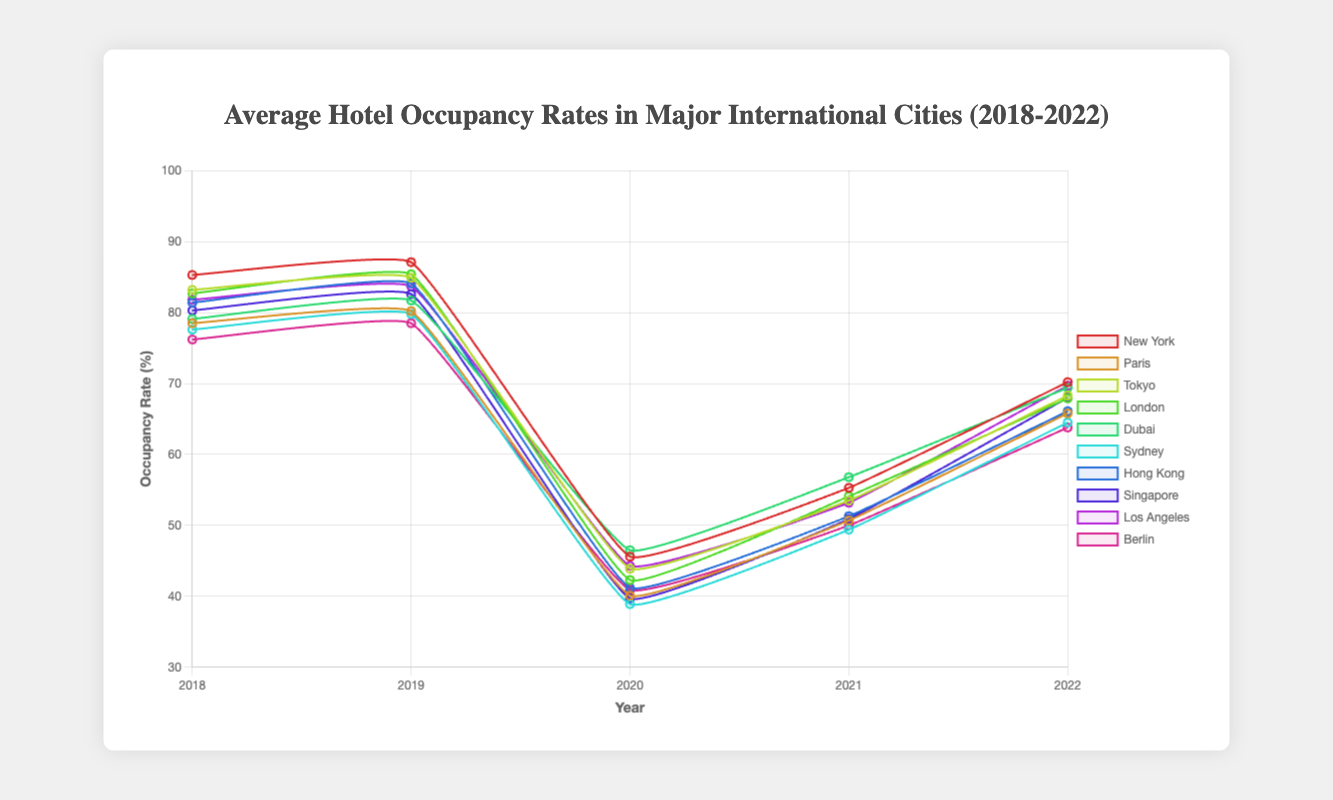Which city had the highest hotel occupancy rate in 2019? To find the city with the highest occupancy rate in 2019, look at the dataset for 2019 and identify the city with the highest percentage. New York has the highest occupancy rate at 87.1%.
Answer: New York How did the occupancy rate of New York change from 2019 to 2020? To identify the change, subtract the 2020 occupancy rate of New York (45.6%) from the 2019 occupancy rate (87.1%). The change is 87.1% - 45.6% = 41.5%.
Answer: Decreased by 41.5% Which city had the lowest occupancy rate in 2021? Reviewing the data for 2021, Sydney had the lowest occupancy rate at 49.4%.
Answer: Sydney Among Paris, Tokyo, and London, which city had the highest average occupancy rate over the five years? Calculate the average for each city by summing their annual occupancy rates and dividing by 5. Paris: (78.5 + 80.2 + 40.1 + 50.7 + 65.8) / 5 = 63.06%, Tokyo: (83.2 + 84.9 + 43.9 + 53.5 + 68.3) / 5 = 66.76%, London: (82.7 + 85.4 + 42.3 + 54.1 + 67.9) / 5 = 66.48%. Tokyo has the highest average.
Answer: Tokyo Which city's occupancy rate returned closest to its 2018 value by 2022? Compare the 2022 occupancy rate of each city with their 2018 rate and find the smallest difference. New York: 15.1%, Paris: 12.7%, Tokyo: 14.9%, London: 15.2%, Dubai: 9.7%, Sydney: 13.1%, Hong Kong: 15.3%, Singapore: 12.3%, Los Angeles: 12.1%, Berlin: 12.4%. Singapore has the smallest difference.
Answer: Singapore Did any city's occupancy rate increase continuously between 2020 and 2022? Observe the rates for each city between 2020 and 2022 to identify continuous increase. New York: Yes (45.6, 55.3, 70.2), Paris: Yes (40.1, 50.7, 65.8), Tokyo: Yes (43.9, 53.5, 68.3), London: Yes (42.3, 54.1, 67.9), Dubai: Yes (46.5, 56.8, 69.4), Sydney: Yes (38.9, 49.4, 64.5), Hong Kong: Yes (41.2, 51.3, 66.1), Singapore: Yes (39.7, 50.9, 68), Los Angeles: Yes (44.3, 53.2, 69.7), Berlin: Yes (40.9, 50.0, 63.8). All cities show an increase.
Answer: All cities Which city saw the highest occupancy rate drop between any two consecutive years, and what was the percentage drop? Calculate the difference in occupancy rates for each city between consecutive years and identify the highest drop. For New York: (45.6 - 87.1) = 41.5%, Paris: (40.1 - 80.2) = 40.1%, Tokyo: (43.9 - 84.9) = 41.0%, London: (42.3 - 85.4) = 43.1%, Dubai: (46.5 - 81.7)= 35.2%, Sydney: (38.9 - 79.8) = 40.9%, Hong Kong: (41.2 - 84.1) = 42.9%, Singapore: (39.7 - 82.6) = 42.9%, Los Angeles: (44.3 - 83.7) = 39.4%, Berlin: (40.9 - 78.5) = 37.6%. London has the highest drop of 43.1%.
Answer: London, 43.1% What is the overall trend in hotel occupancy rates over the five years for New York? Analyzing the data points for New York: 85.3 (2018) to 87.1 (2019), increased; 87.1 (2019) to 45.6 (2020), dropped sharply; 45.6 (2020) to 55.3 (2021), increased; 55.3 (2021) to 70.2 (2022), increased. The trend shows an increase from 2018 to 2019, a significant drop in 2020, then a steady recovery through 2022.
Answer: Recovery after a drop 